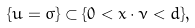<formula> <loc_0><loc_0><loc_500><loc_500>\{ u = \sigma \} \subset \{ 0 < x \cdot \nu < d \} ,</formula> 